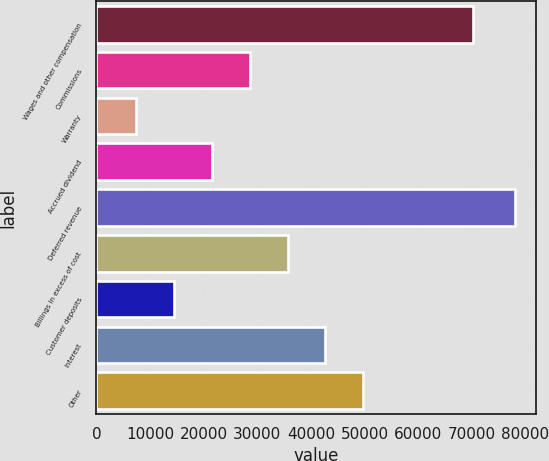<chart> <loc_0><loc_0><loc_500><loc_500><bar_chart><fcel>Wages and other compensation<fcel>Commissions<fcel>Warranty<fcel>Accrued dividend<fcel>Deferred revenue<fcel>Billings in excess of cost<fcel>Customer deposits<fcel>Interest<fcel>Other<nl><fcel>70164<fcel>28561.8<fcel>7341<fcel>21488.2<fcel>78077<fcel>35635.4<fcel>14414.6<fcel>42709<fcel>49782.6<nl></chart> 